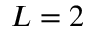Convert formula to latex. <formula><loc_0><loc_0><loc_500><loc_500>L = 2</formula> 